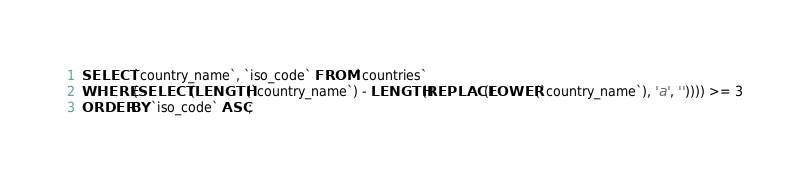<code> <loc_0><loc_0><loc_500><loc_500><_SQL_>SELECT `country_name`, `iso_code` FROM `countries`
WHERE (SELECT (LENGTH(`country_name`) - LENGTH(REPLACE(LOWER(`country_name`), 'a', '')))) >= 3
ORDER BY `iso_code` ASC;</code> 